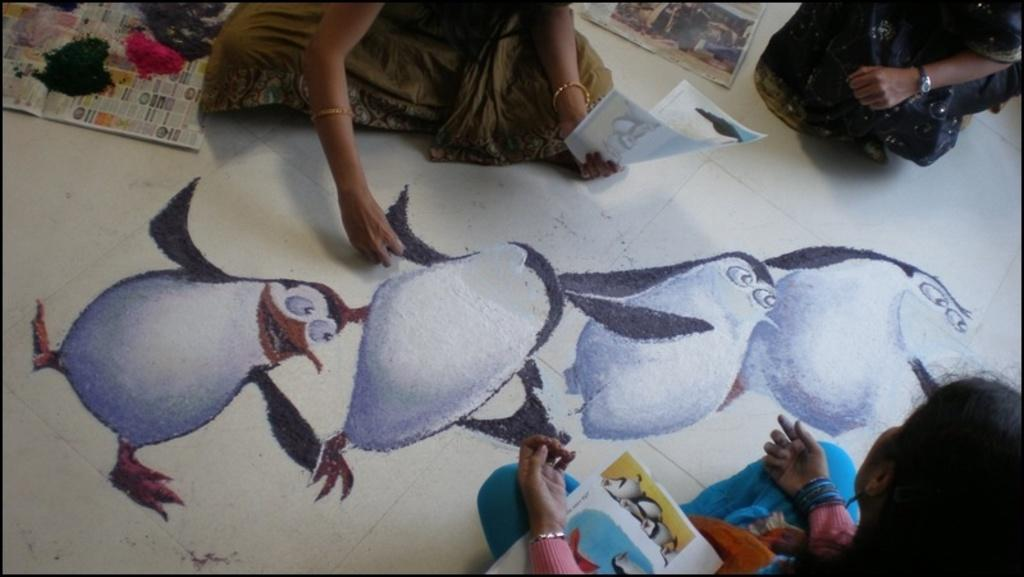What are the people in the image doing? The people in the image are sitting and drawing on the floor. What materials are being used for drawing? There are papers visible in the image, and there are colors on the papers. What type of metal support can be seen in the image? There is no metal support present in the image. How does the acoustics of the room affect the drawing process in the image? The provided facts do not mention anything about the acoustics of the room, so we cannot determine how it affects the drawing process in the image. 